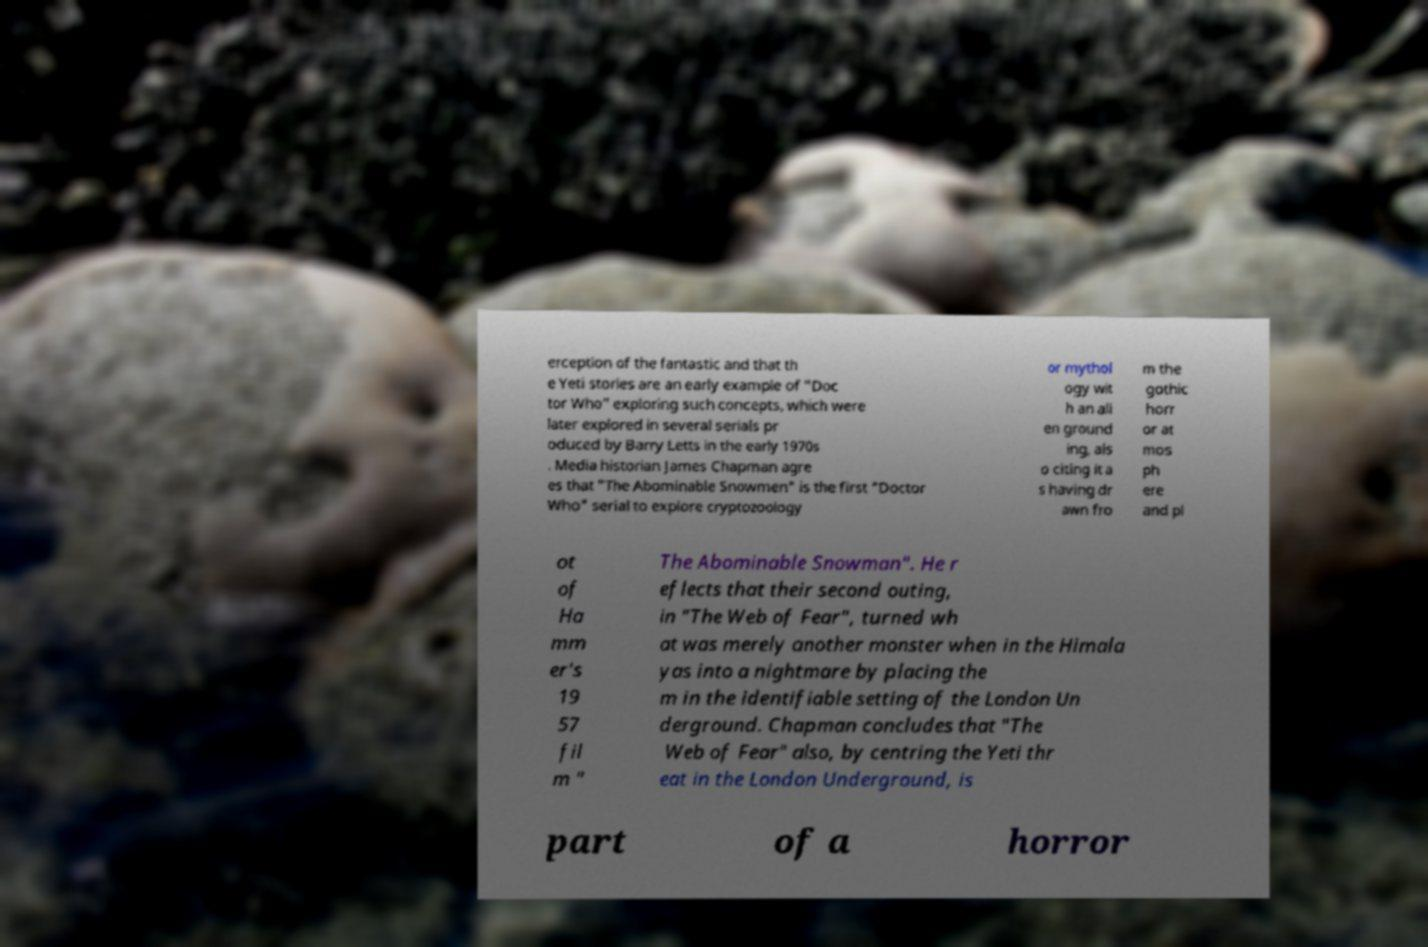Please read and relay the text visible in this image. What does it say? erception of the fantastic and that th e Yeti stories are an early example of "Doc tor Who" exploring such concepts, which were later explored in several serials pr oduced by Barry Letts in the early 1970s . Media historian James Chapman agre es that "The Abominable Snowmen" is the first "Doctor Who" serial to explore cryptozoology or mythol ogy wit h an ali en ground ing, als o citing it a s having dr awn fro m the gothic horr or at mos ph ere and pl ot of Ha mm er's 19 57 fil m " The Abominable Snowman". He r eflects that their second outing, in "The Web of Fear", turned wh at was merely another monster when in the Himala yas into a nightmare by placing the m in the identifiable setting of the London Un derground. Chapman concludes that "The Web of Fear" also, by centring the Yeti thr eat in the London Underground, is part of a horror 